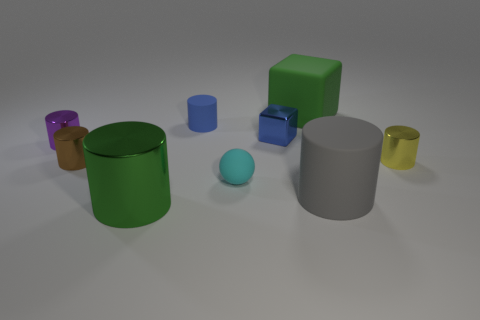Subtract 1 cylinders. How many cylinders are left? 5 Subtract all green cylinders. How many cylinders are left? 5 Subtract all brown metallic cylinders. How many cylinders are left? 5 Subtract all red cylinders. Subtract all blue blocks. How many cylinders are left? 6 Add 1 large purple spheres. How many objects exist? 10 Subtract all blocks. How many objects are left? 7 Add 9 brown metal objects. How many brown metal objects are left? 10 Add 3 small cyan objects. How many small cyan objects exist? 4 Subtract 0 gray balls. How many objects are left? 9 Subtract all large red blocks. Subtract all gray rubber cylinders. How many objects are left? 8 